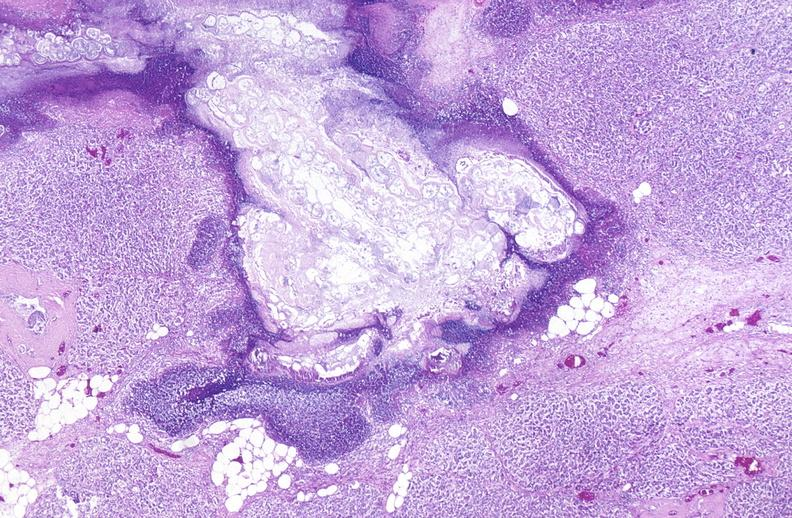does this image show pancreatic fat necrosis?
Answer the question using a single word or phrase. Yes 